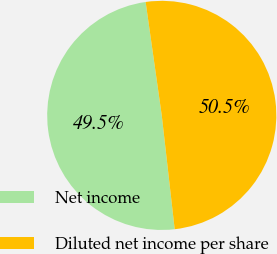<chart> <loc_0><loc_0><loc_500><loc_500><pie_chart><fcel>Net income<fcel>Diluted net income per share<nl><fcel>49.55%<fcel>50.45%<nl></chart> 